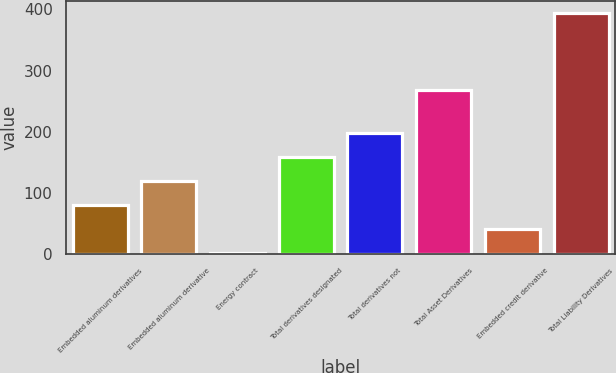Convert chart to OTSL. <chart><loc_0><loc_0><loc_500><loc_500><bar_chart><fcel>Embedded aluminum derivatives<fcel>Embedded aluminum derivative<fcel>Energy contract<fcel>Total derivatives designated<fcel>Total derivatives not<fcel>Total Asset Derivatives<fcel>Embedded credit derivative<fcel>Total Liability Derivatives<nl><fcel>80.4<fcel>119.6<fcel>2<fcel>158.8<fcel>198<fcel>268<fcel>41.2<fcel>394<nl></chart> 